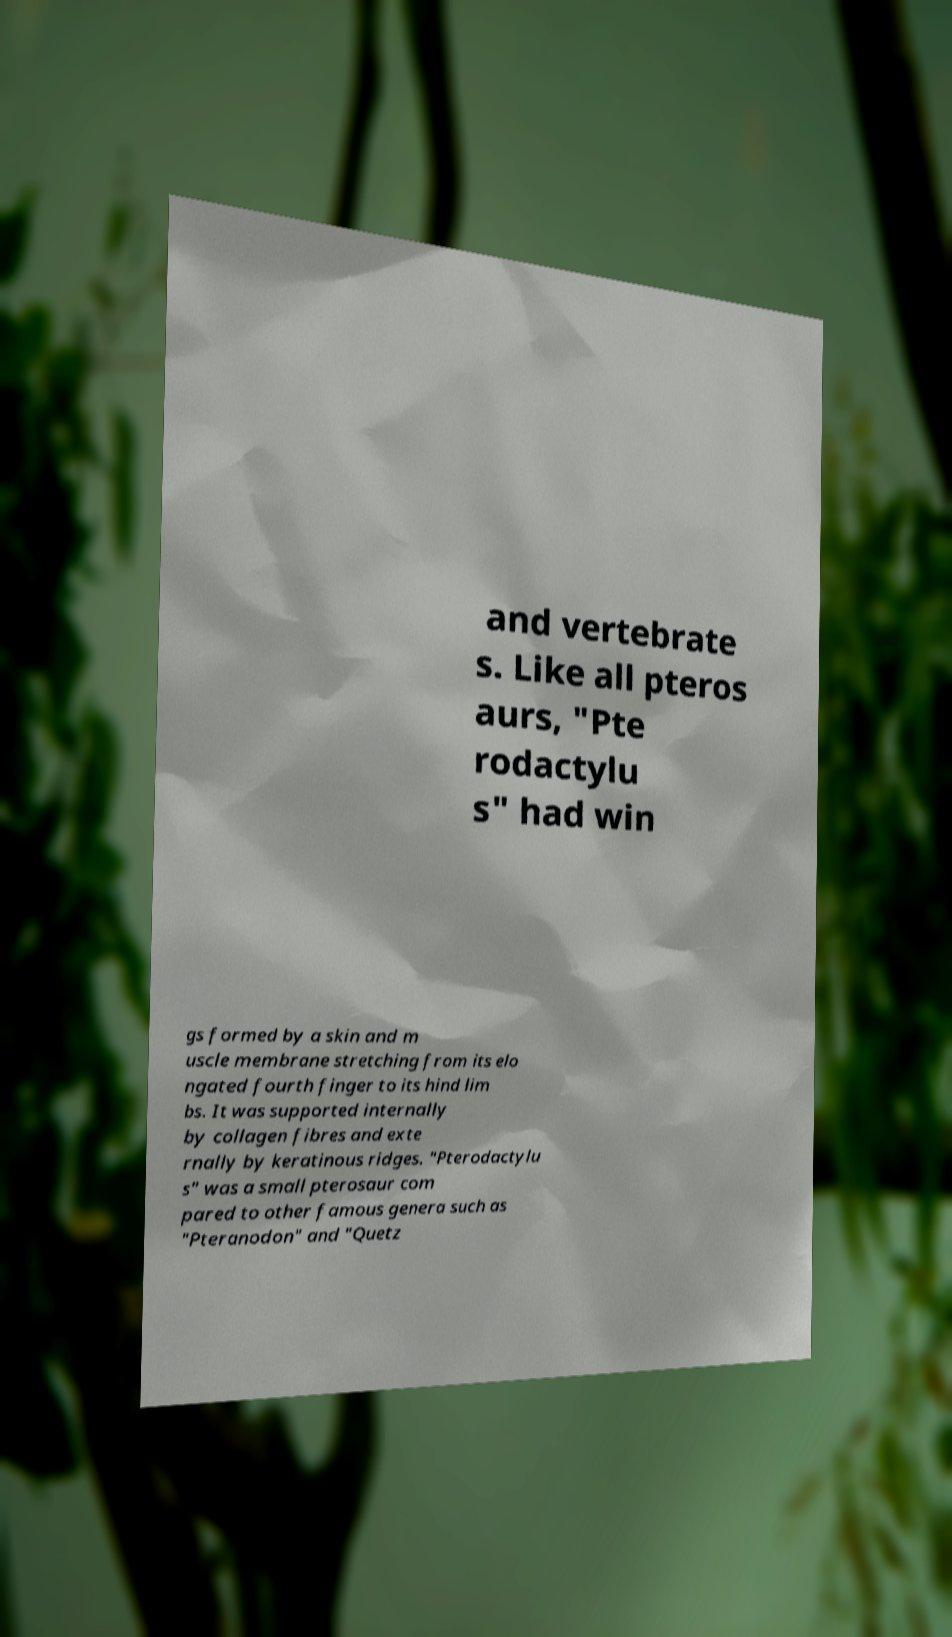There's text embedded in this image that I need extracted. Can you transcribe it verbatim? and vertebrate s. Like all pteros aurs, "Pte rodactylu s" had win gs formed by a skin and m uscle membrane stretching from its elo ngated fourth finger to its hind lim bs. It was supported internally by collagen fibres and exte rnally by keratinous ridges. "Pterodactylu s" was a small pterosaur com pared to other famous genera such as "Pteranodon" and "Quetz 